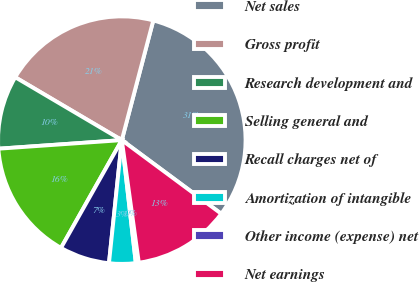Convert chart to OTSL. <chart><loc_0><loc_0><loc_500><loc_500><pie_chart><fcel>Net sales<fcel>Gross profit<fcel>Research development and<fcel>Selling general and<fcel>Recall charges net of<fcel>Amortization of intangible<fcel>Other income (expense) net<fcel>Net earnings<nl><fcel>31.05%<fcel>20.61%<fcel>9.59%<fcel>15.72%<fcel>6.52%<fcel>3.46%<fcel>0.39%<fcel>12.66%<nl></chart> 